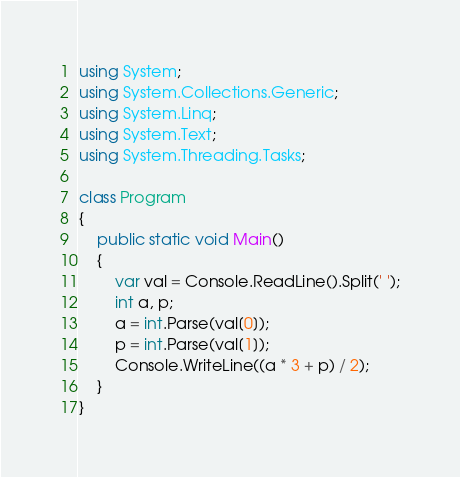<code> <loc_0><loc_0><loc_500><loc_500><_C#_>using System;
using System.Collections.Generic;
using System.Linq;
using System.Text;
using System.Threading.Tasks;

class Program
{
    public static void Main()
    {
        var val = Console.ReadLine().Split(' ');
        int a, p;
        a = int.Parse(val[0]);
        p = int.Parse(val[1]);
        Console.WriteLine((a * 3 + p) / 2);
    }
}
</code> 